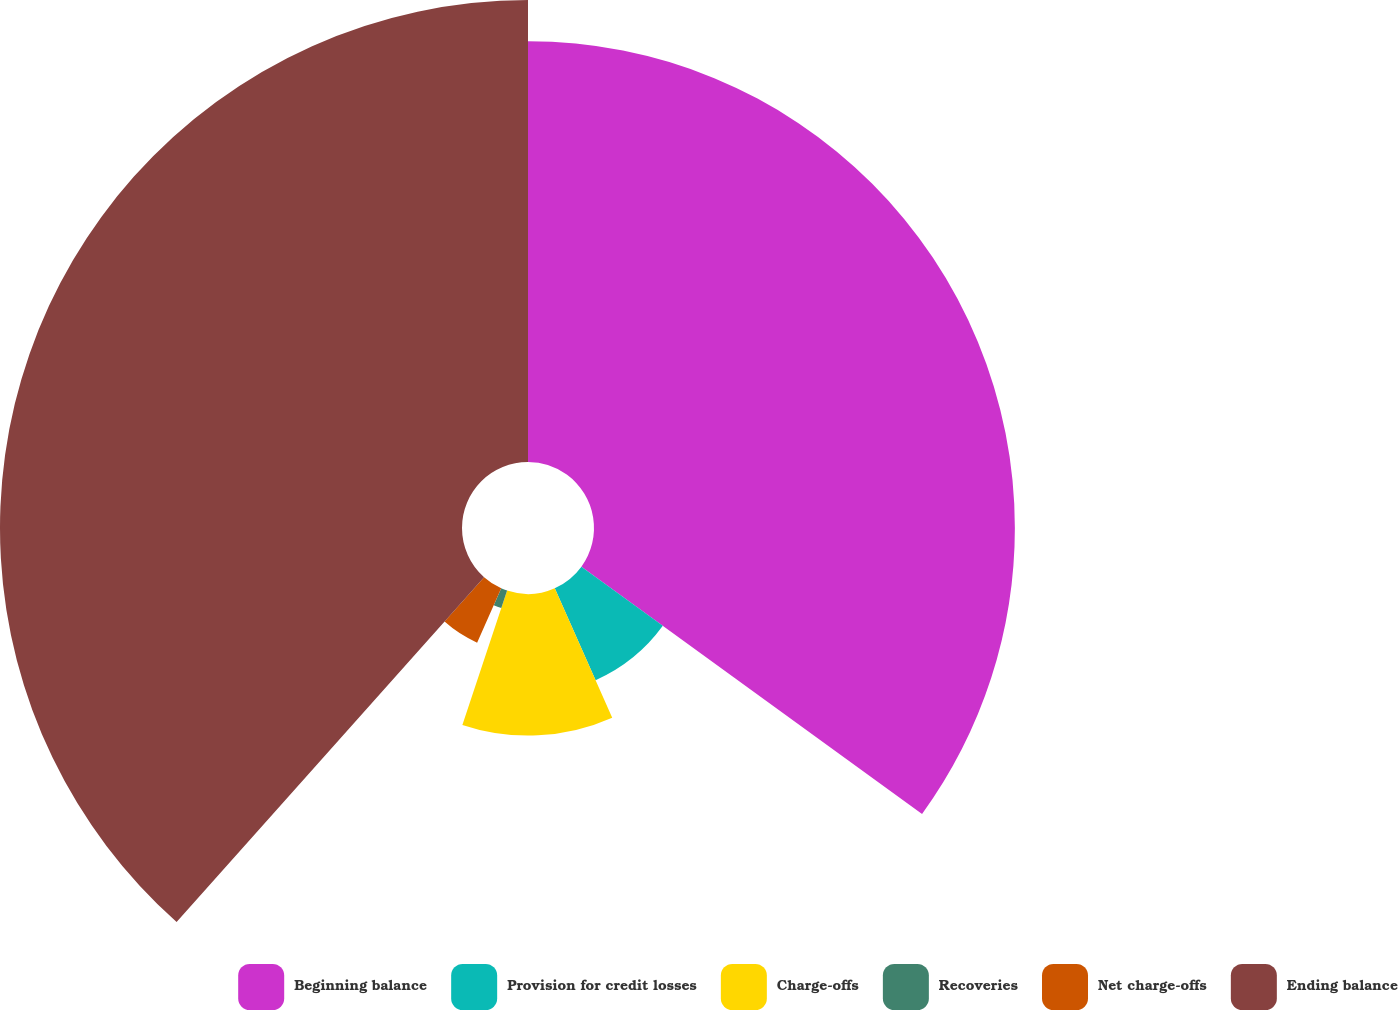Convert chart to OTSL. <chart><loc_0><loc_0><loc_500><loc_500><pie_chart><fcel>Beginning balance<fcel>Provision for credit losses<fcel>Charge-offs<fcel>Recoveries<fcel>Net charge-offs<fcel>Ending balance<nl><fcel>34.99%<fcel>8.36%<fcel>11.77%<fcel>1.53%<fcel>4.94%<fcel>38.41%<nl></chart> 